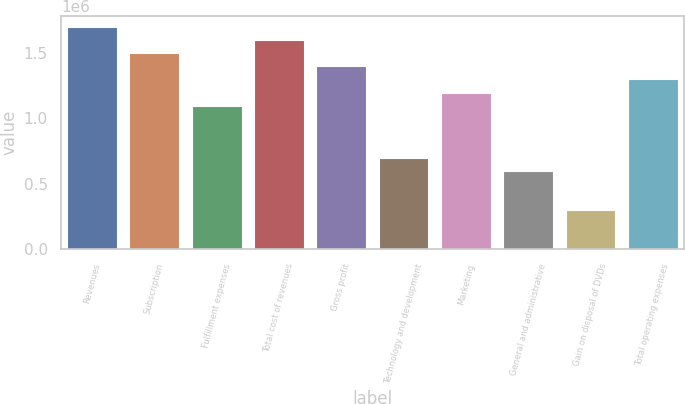Convert chart. <chart><loc_0><loc_0><loc_500><loc_500><bar_chart><fcel>Revenues<fcel>Subscription<fcel>Fulfillment expenses<fcel>Total cost of revenues<fcel>Gross profit<fcel>Technology and development<fcel>Marketing<fcel>General and administrative<fcel>Gain on disposal of DVDs<fcel>Total operating expenses<nl><fcel>1.69432e+06<fcel>1.49499e+06<fcel>1.09633e+06<fcel>1.59466e+06<fcel>1.39532e+06<fcel>697662<fcel>1.19599e+06<fcel>597996<fcel>298998<fcel>1.29566e+06<nl></chart> 